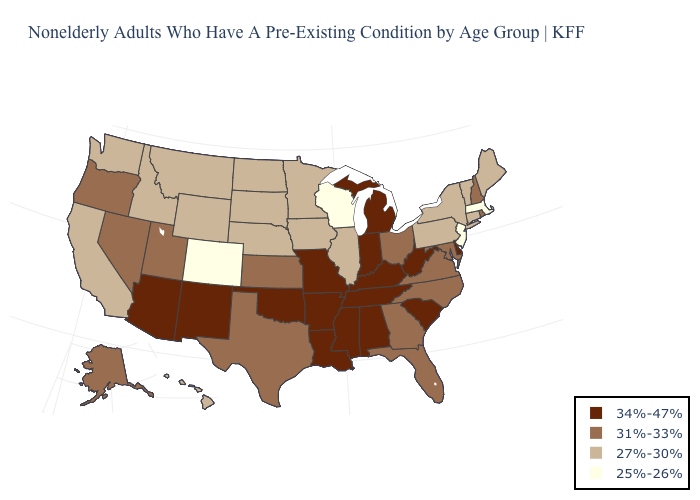Which states have the lowest value in the MidWest?
Write a very short answer. Wisconsin. What is the value of Ohio?
Be succinct. 31%-33%. Among the states that border Iowa , does Illinois have the highest value?
Give a very brief answer. No. Does Indiana have the highest value in the USA?
Concise answer only. Yes. What is the value of Nebraska?
Keep it brief. 27%-30%. What is the highest value in states that border Mississippi?
Answer briefly. 34%-47%. Among the states that border Kansas , which have the lowest value?
Keep it brief. Colorado. Name the states that have a value in the range 25%-26%?
Concise answer only. Colorado, Massachusetts, New Jersey, Wisconsin. How many symbols are there in the legend?
Write a very short answer. 4. Name the states that have a value in the range 34%-47%?
Quick response, please. Alabama, Arizona, Arkansas, Delaware, Indiana, Kentucky, Louisiana, Michigan, Mississippi, Missouri, New Mexico, Oklahoma, South Carolina, Tennessee, West Virginia. Name the states that have a value in the range 27%-30%?
Give a very brief answer. California, Connecticut, Hawaii, Idaho, Illinois, Iowa, Maine, Minnesota, Montana, Nebraska, New York, North Dakota, Pennsylvania, South Dakota, Vermont, Washington, Wyoming. What is the value of North Carolina?
Answer briefly. 31%-33%. Among the states that border Nebraska , which have the lowest value?
Answer briefly. Colorado. Among the states that border Washington , does Oregon have the lowest value?
Concise answer only. No. What is the highest value in the USA?
Answer briefly. 34%-47%. 